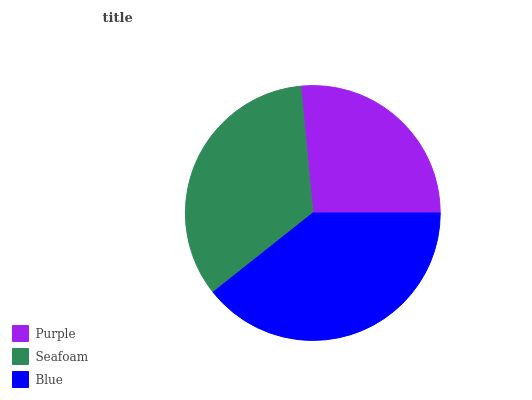Is Purple the minimum?
Answer yes or no. Yes. Is Blue the maximum?
Answer yes or no. Yes. Is Seafoam the minimum?
Answer yes or no. No. Is Seafoam the maximum?
Answer yes or no. No. Is Seafoam greater than Purple?
Answer yes or no. Yes. Is Purple less than Seafoam?
Answer yes or no. Yes. Is Purple greater than Seafoam?
Answer yes or no. No. Is Seafoam less than Purple?
Answer yes or no. No. Is Seafoam the high median?
Answer yes or no. Yes. Is Seafoam the low median?
Answer yes or no. Yes. Is Blue the high median?
Answer yes or no. No. Is Blue the low median?
Answer yes or no. No. 